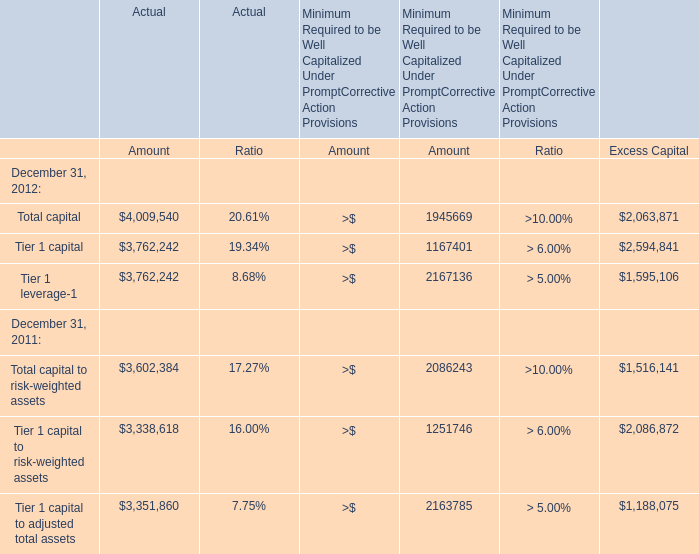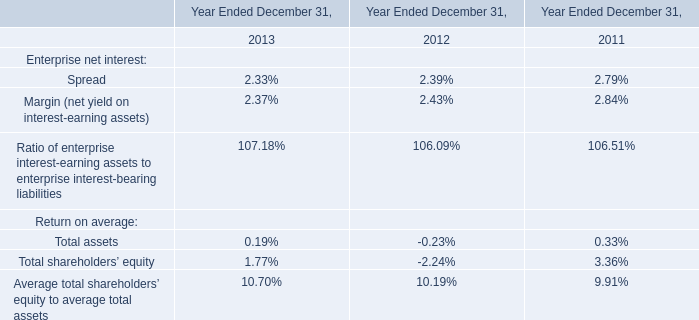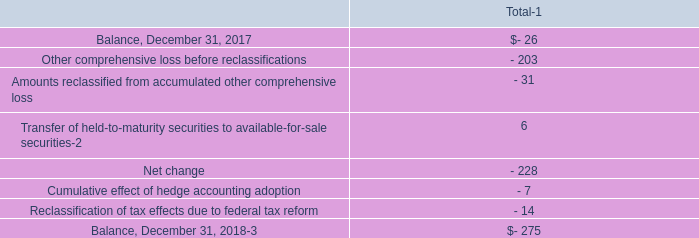what was the ratio of the pre-tax gain on the securities transferred from held-to-maturity securities to available-for-sale securities \\n 
Computations: (7 / 4.7)
Answer: 1.48936. 